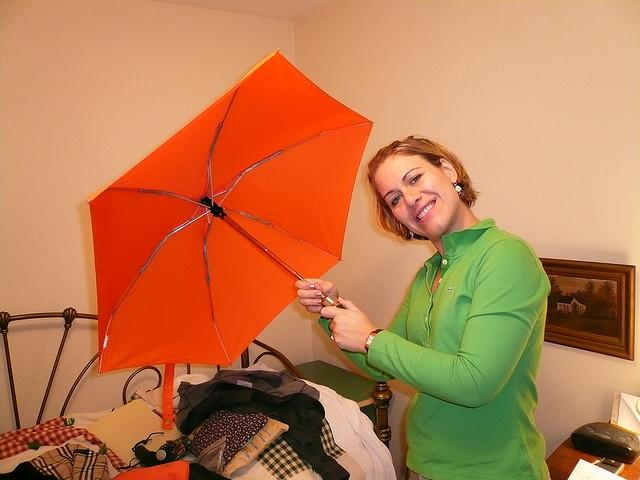What color is this woman's shirt?
Answer briefly. Green. What is on the wall behind the woman with the green shirt?
Write a very short answer. Picture. How big is the umbrella?
Short answer required. Small. What color is the woman's umbrella?
Answer briefly. Orange. Is she happy?
Keep it brief. Yes. Are these stuffed animals?
Concise answer only. No. What is the white umbrella being used for?
Concise answer only. There is no white umbrella. 